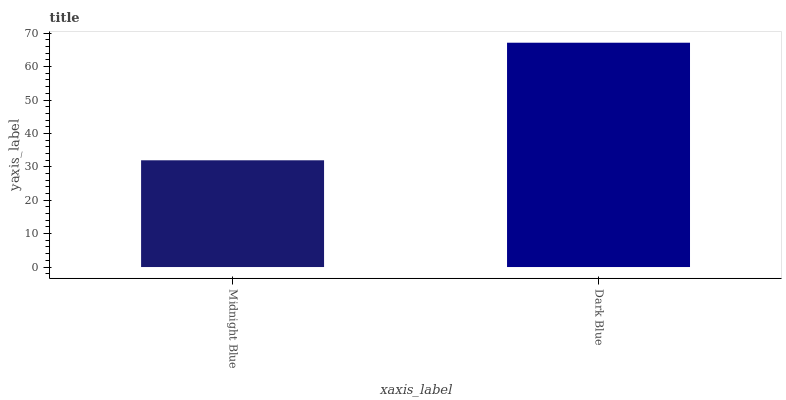Is Dark Blue the minimum?
Answer yes or no. No. Is Dark Blue greater than Midnight Blue?
Answer yes or no. Yes. Is Midnight Blue less than Dark Blue?
Answer yes or no. Yes. Is Midnight Blue greater than Dark Blue?
Answer yes or no. No. Is Dark Blue less than Midnight Blue?
Answer yes or no. No. Is Dark Blue the high median?
Answer yes or no. Yes. Is Midnight Blue the low median?
Answer yes or no. Yes. Is Midnight Blue the high median?
Answer yes or no. No. Is Dark Blue the low median?
Answer yes or no. No. 